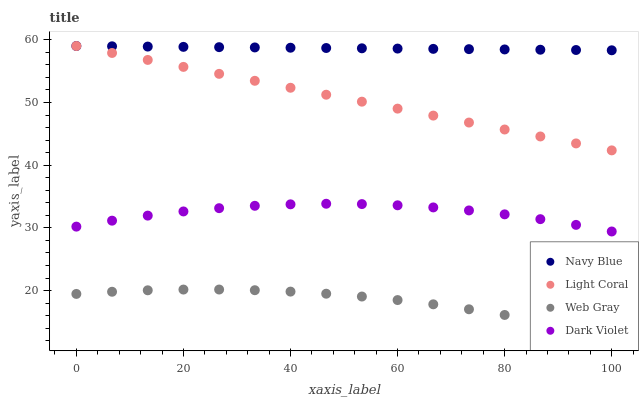Does Web Gray have the minimum area under the curve?
Answer yes or no. Yes. Does Navy Blue have the maximum area under the curve?
Answer yes or no. Yes. Does Navy Blue have the minimum area under the curve?
Answer yes or no. No. Does Web Gray have the maximum area under the curve?
Answer yes or no. No. Is Light Coral the smoothest?
Answer yes or no. Yes. Is Dark Violet the roughest?
Answer yes or no. Yes. Is Navy Blue the smoothest?
Answer yes or no. No. Is Navy Blue the roughest?
Answer yes or no. No. Does Web Gray have the lowest value?
Answer yes or no. Yes. Does Navy Blue have the lowest value?
Answer yes or no. No. Does Navy Blue have the highest value?
Answer yes or no. Yes. Does Web Gray have the highest value?
Answer yes or no. No. Is Web Gray less than Dark Violet?
Answer yes or no. Yes. Is Dark Violet greater than Web Gray?
Answer yes or no. Yes. Does Light Coral intersect Navy Blue?
Answer yes or no. Yes. Is Light Coral less than Navy Blue?
Answer yes or no. No. Is Light Coral greater than Navy Blue?
Answer yes or no. No. Does Web Gray intersect Dark Violet?
Answer yes or no. No. 